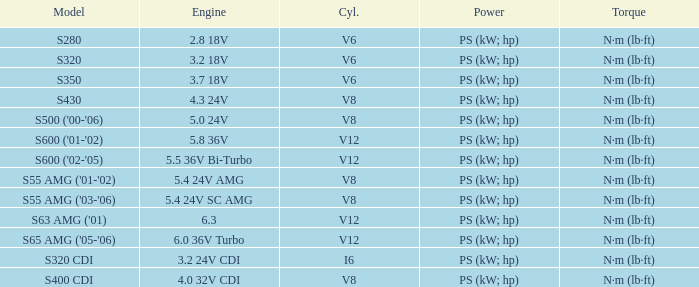Which Engine has a Model of s320 cdi? 3.2 24V CDI. 